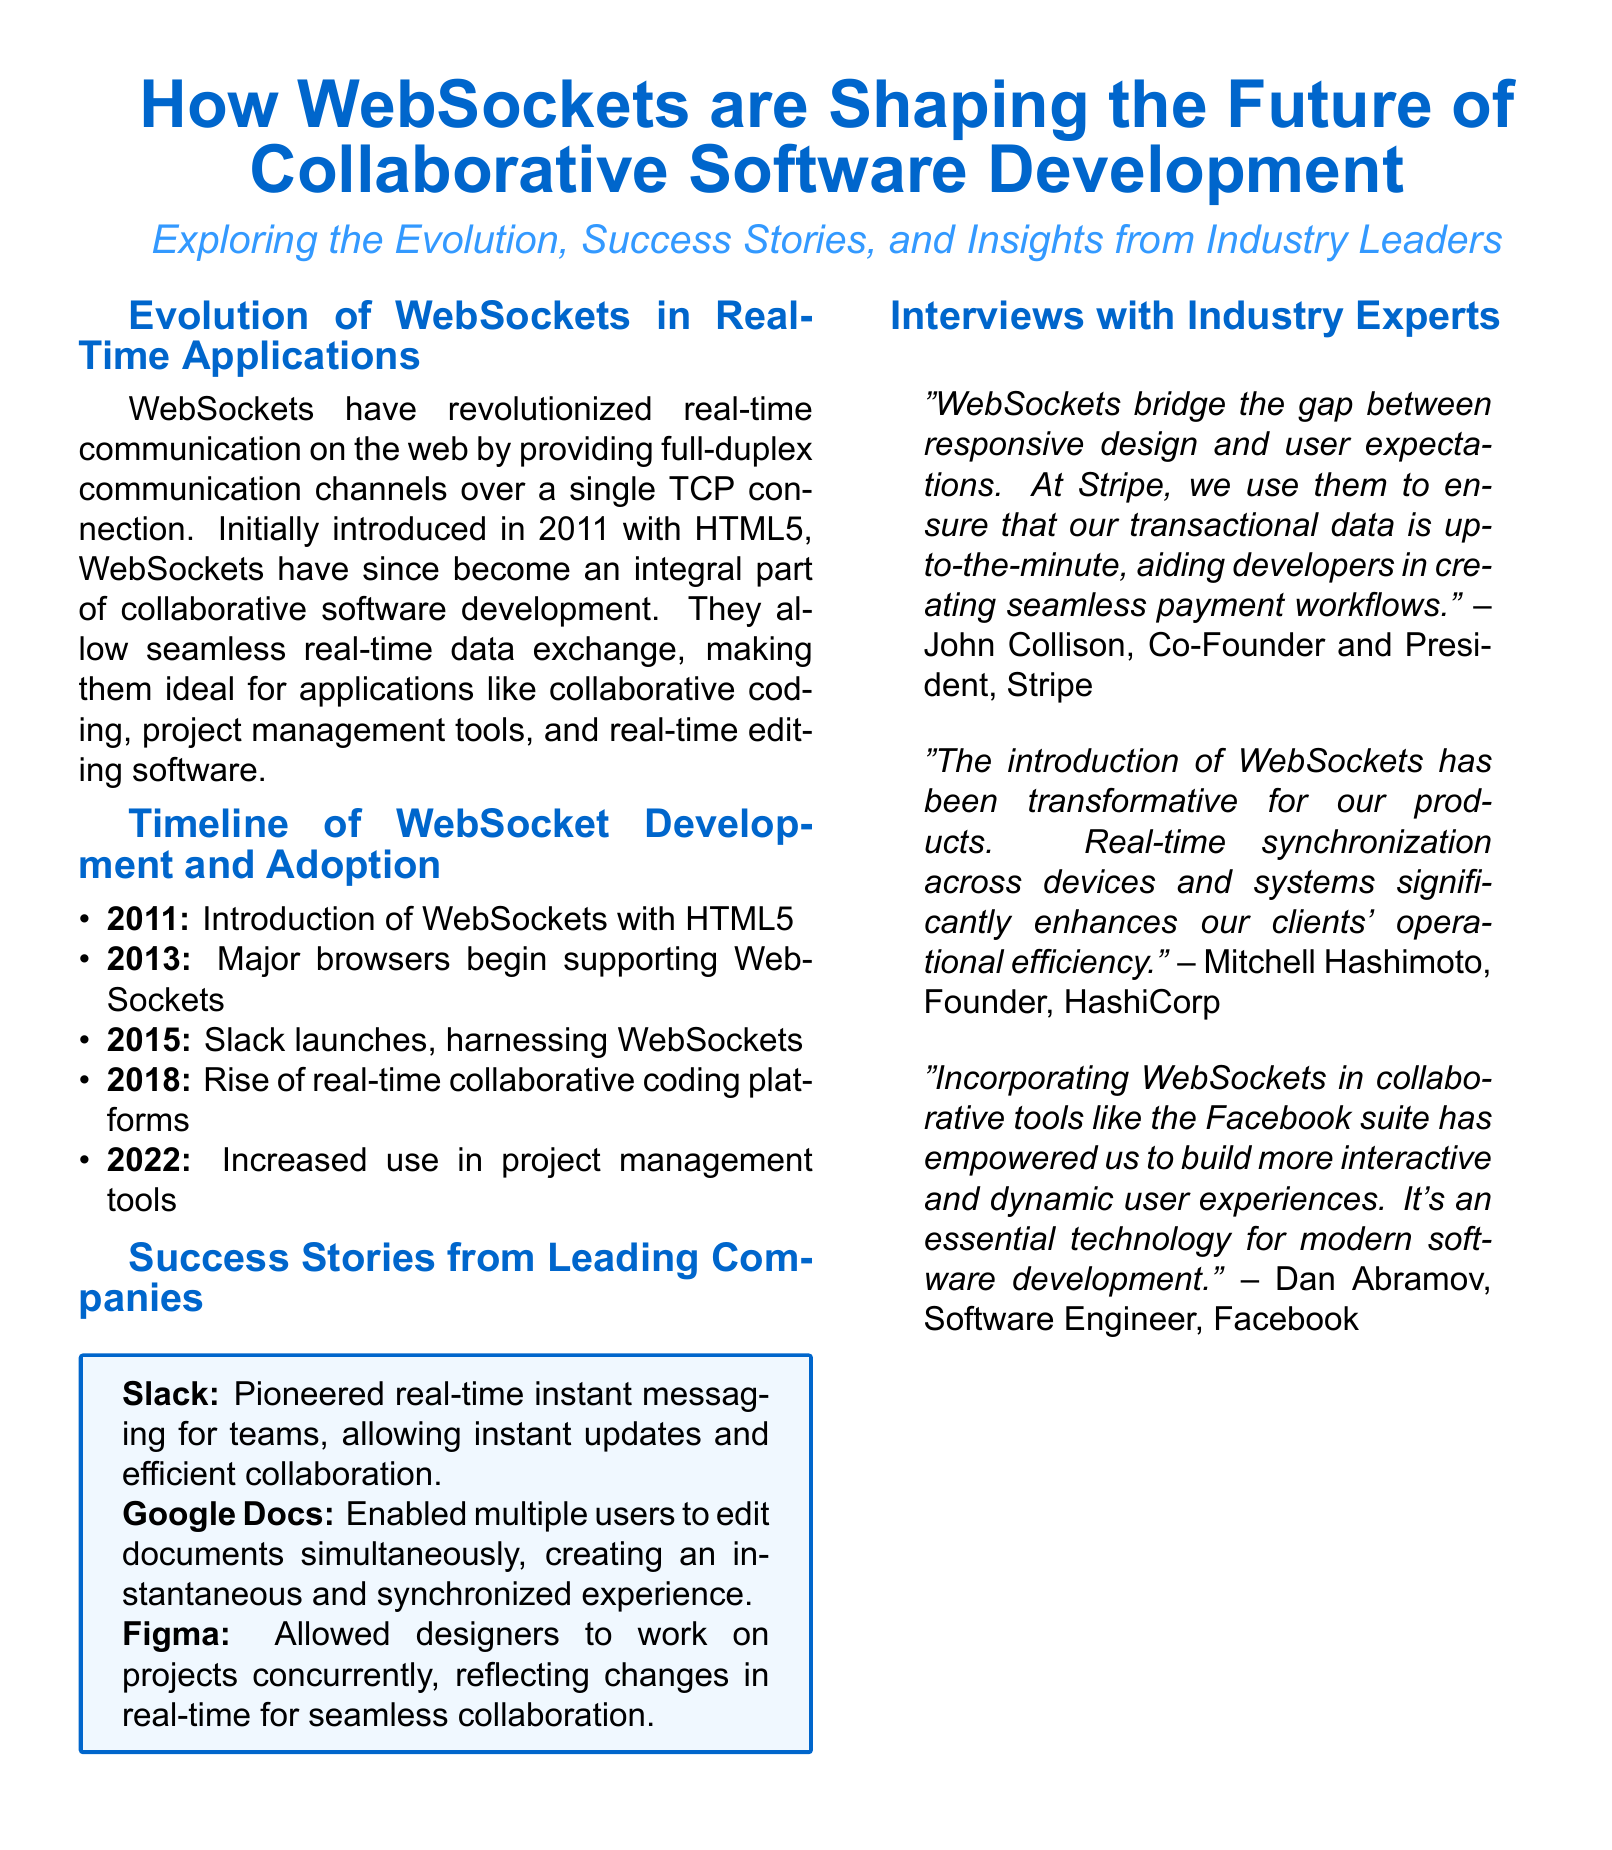What year were WebSockets introduced? WebSockets were introduced in 2011 as part of HTML5.
Answer: 2011 Which company launched a product using WebSockets in 2015? Slack launched its product utilizing WebSockets in 2015.
Answer: Slack What functionality does Google Docs provide that utilizes WebSockets? Google Docs enables multiple users to edit documents simultaneously, utilizing real-time data exchange.
Answer: Editing documents simultaneously Who is the co-founder of Stripe mentioned in the document? John Collison is mentioned as the co-founder and president of Stripe.
Answer: John Collison In what year did the rise of real-time collaborative coding platforms occur? The rise of real-time collaborative coding platforms occurred in 2018.
Answer: 2018 What does Mitchell Hashimoto claim has been transformed due to WebSockets? Mitchell Hashimoto claims that real-time synchronization across devices and systems has been transformed.
Answer: Real-time synchronization What is the main benefit of WebSockets according to Dan Abramov from Facebook? The main benefit is building more interactive and dynamic user experiences.
Answer: Interactive and dynamic user experiences Which technology is noted as essential for modern software development? WebSockets are noted as essential for modern software development.
Answer: WebSockets When did major browsers begin to support WebSockets? Major browsers began supporting WebSockets in 2013.
Answer: 2013 